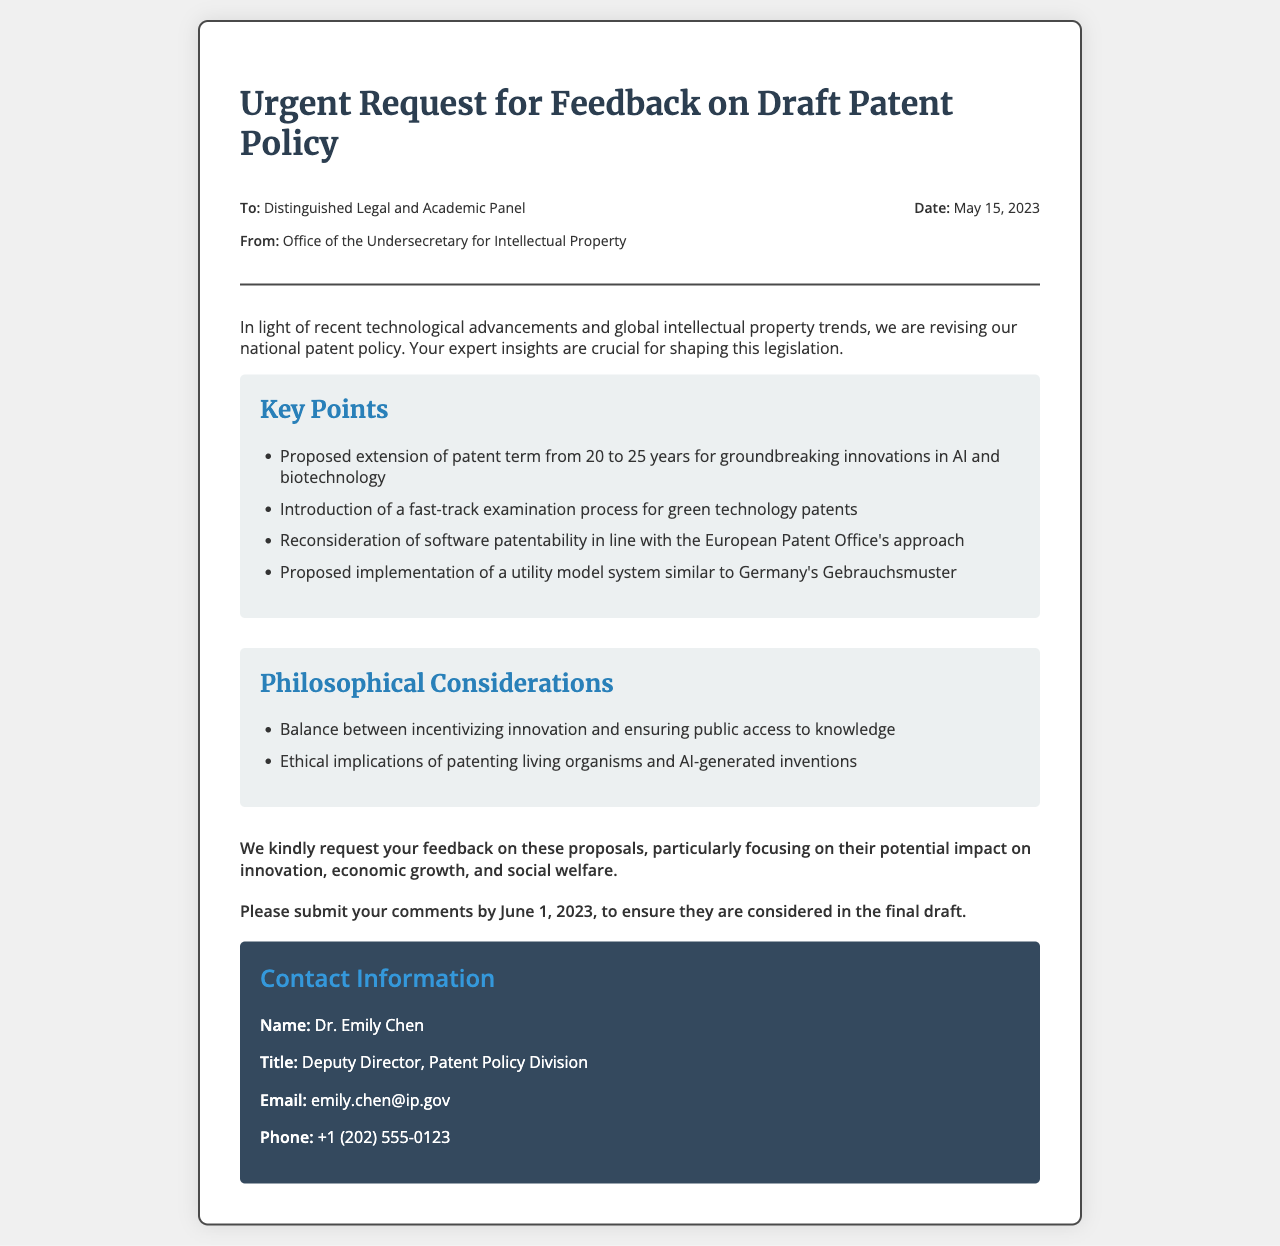What is the date of the document? The date is mentioned in the header section of the document.
Answer: May 15, 2023 Who is the sender of the fax? The sender is specified at the top of the document under the "From" section.
Answer: Office of the Undersecretary for Intellectual Property What is one of the proposed key points regarding patent terms? The key points are listed in a section specifically labeled for them.
Answer: Extension of patent term from 20 to 25 years What is the deadline for feedback submissions? The deadline is clearly stated in the document under the "deadline" section.
Answer: June 1, 2023 What philosophical consideration is mentioned regarding patenting innovations? The document lists philosophical considerations relevant to the patent policy.
Answer: Balance between incentivizing innovation and ensuring public access to knowledge What is the contact title of Dr. Emily Chen? This information is provided in the contact information section of the document.
Answer: Deputy Director, Patent Policy Division Which type of technology is mentioned for a fast-track examination process? The key points indicate specific technologies that relate to the fast-track process.
Answer: Green technology patents What does the document describe as a proposed system similar to Germany's? The context specifies a system being proposed that aligns with another country's practices.
Answer: Utility model system 